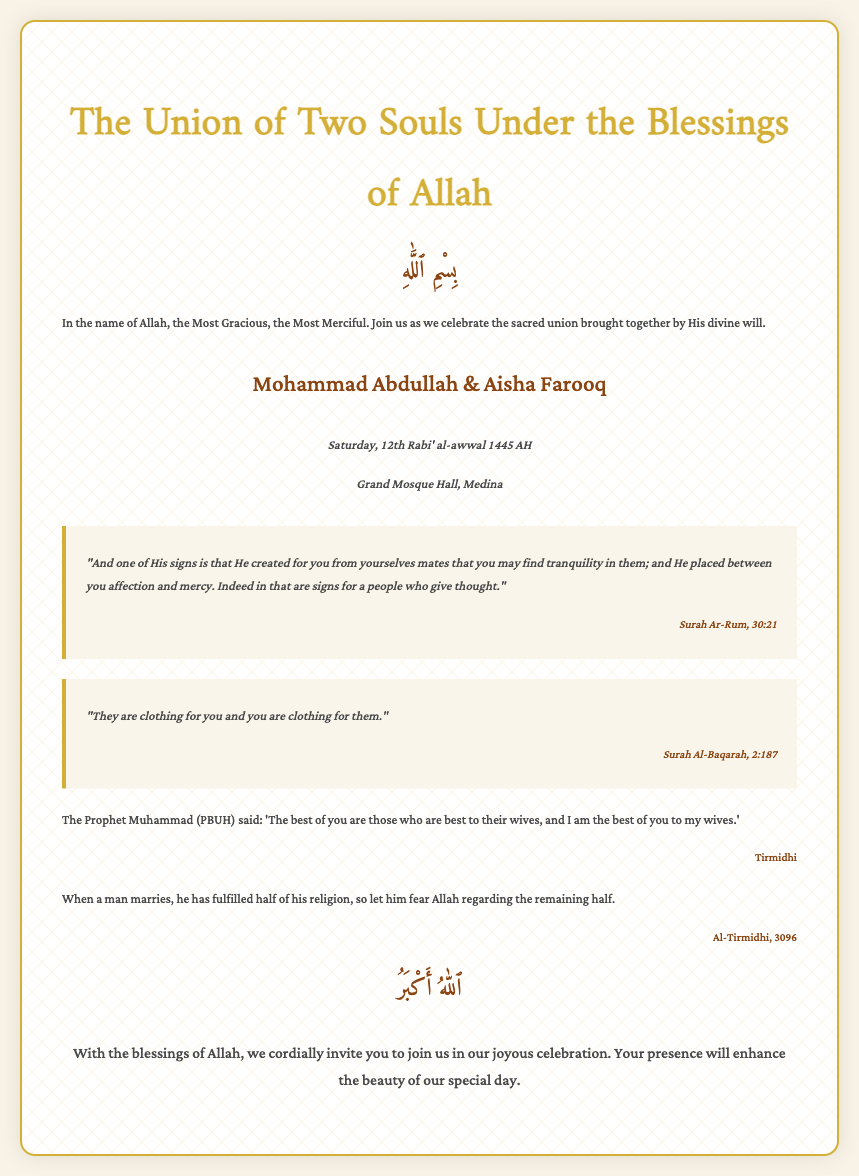What is the date of the wedding? The wedding is scheduled for Saturday, 12th Rabi' al-awwal 1445 AH as mentioned in the details section.
Answer: Saturday, 12th Rabi' al-awwal 1445 AH Who are the couple getting married? The names of the couple are clearly stated in the invitation header section.
Answer: Mohammad Abdullah & Aisha Farooq What is the title of the invitation? The title is prominently displayed at the top of the invitation.
Answer: The Union of Two Souls Under the Blessings of Allah Where is the wedding ceremony taking place? The location of the wedding is indicated in the details section.
Answer: Grand Mosque Hall, Medina What is one sign mentioned in the Quran about marriage? This is discussed in one of the quotes from Surah Ar-Rum regarding marriage and signs from Allah.
Answer: "And one of His signs is that He created for you from yourselves mates" What did the Prophet Muhammad (PBUH) say about marriage? A hadith is included that provides insight into the significance of marriage from the Prophet’s teachings.
Answer: "When a man marries, he has fulfilled half of his religion" What theme is emphasized throughout the invitation? The overall theme of the invitation focuses on a divine aspect of the union, which is highlighted through the various texts.
Answer: Blessings of Allah What color is primarily used for the invitation text? The text color is specified in the style section of the document.
Answer: #4a4a4a 